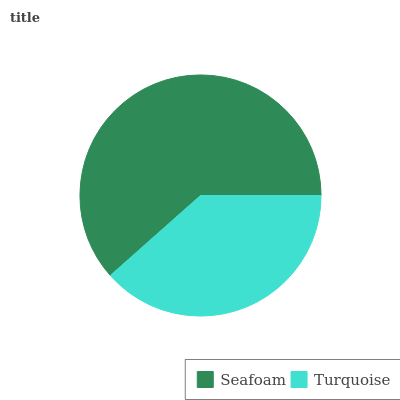Is Turquoise the minimum?
Answer yes or no. Yes. Is Seafoam the maximum?
Answer yes or no. Yes. Is Turquoise the maximum?
Answer yes or no. No. Is Seafoam greater than Turquoise?
Answer yes or no. Yes. Is Turquoise less than Seafoam?
Answer yes or no. Yes. Is Turquoise greater than Seafoam?
Answer yes or no. No. Is Seafoam less than Turquoise?
Answer yes or no. No. Is Seafoam the high median?
Answer yes or no. Yes. Is Turquoise the low median?
Answer yes or no. Yes. Is Turquoise the high median?
Answer yes or no. No. Is Seafoam the low median?
Answer yes or no. No. 